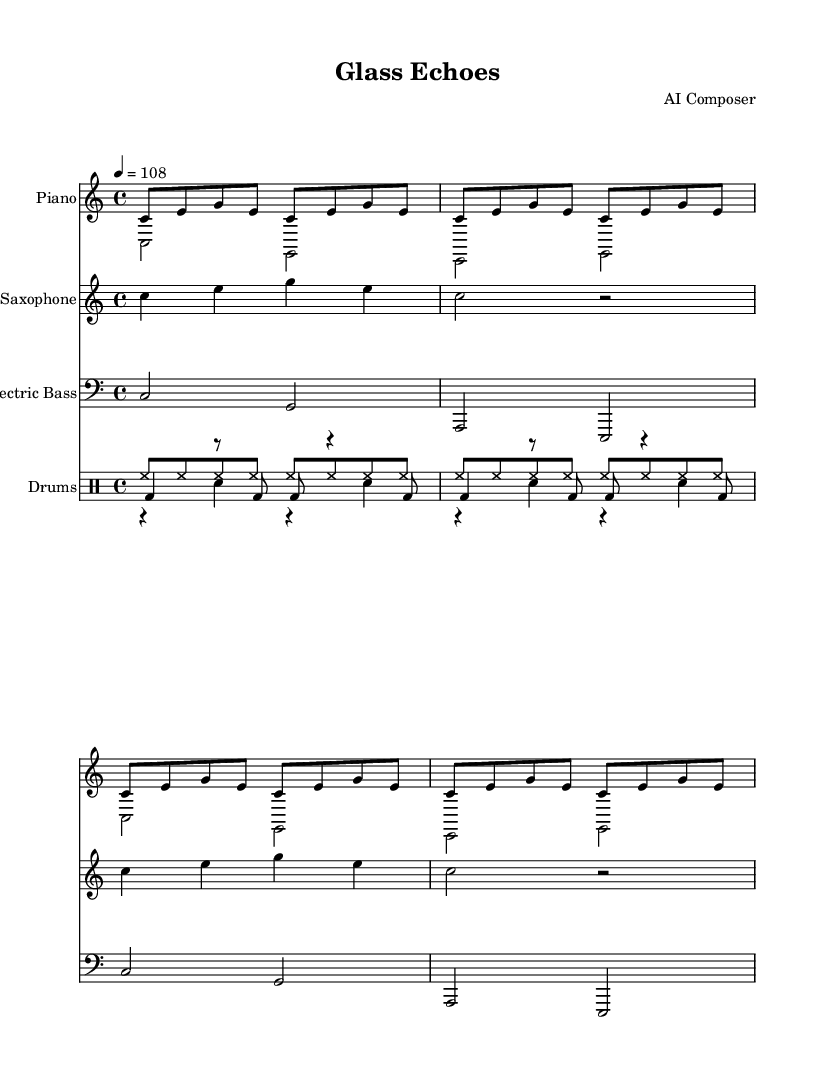What is the key signature of this music? The key signature in the score is C major, which is indicated by the absence of any sharps or flats at the beginning of the staff.
Answer: C major What is the time signature of this piece? The time signature is 4/4, which is indicated at the beginning of the score. This means there are four beats in a measure, and the quarter note gets one beat.
Answer: 4/4 What is the tempo marking given in the score? The tempo marking at the beginning indicates that the piece should be played at a speed of quarter note = 108 beats per minute.
Answer: 108 How many measures does the piano right hand part repeat? The piano right hand part has a pattern that repeats four times, as indicated by the "repeat unfold 4" command at the start of that section.
Answer: 4 What type of ensemble is this score written for? The score is for a Jazz ensemble, which typically includes piano, saxophone, electric bass, and drums, as represented in the different staves and parts of the score.
Answer: Jazz ensemble What rhythmic pattern is used in the drum kick part? The drum kick part includes a rhythmic pattern that utilizes quarter and eighth notes, as seen in the drum notation shown in the score.
Answer: bd4 r8 bd8 bd8 r4 bd8 How is the saxophone part structured in terms of repetition? The saxophone part demonstrates a repetitive structure where a musical phrase is echoed twice, indicated by “repeat unfold 2.”
Answer: Repeat unfold 2 